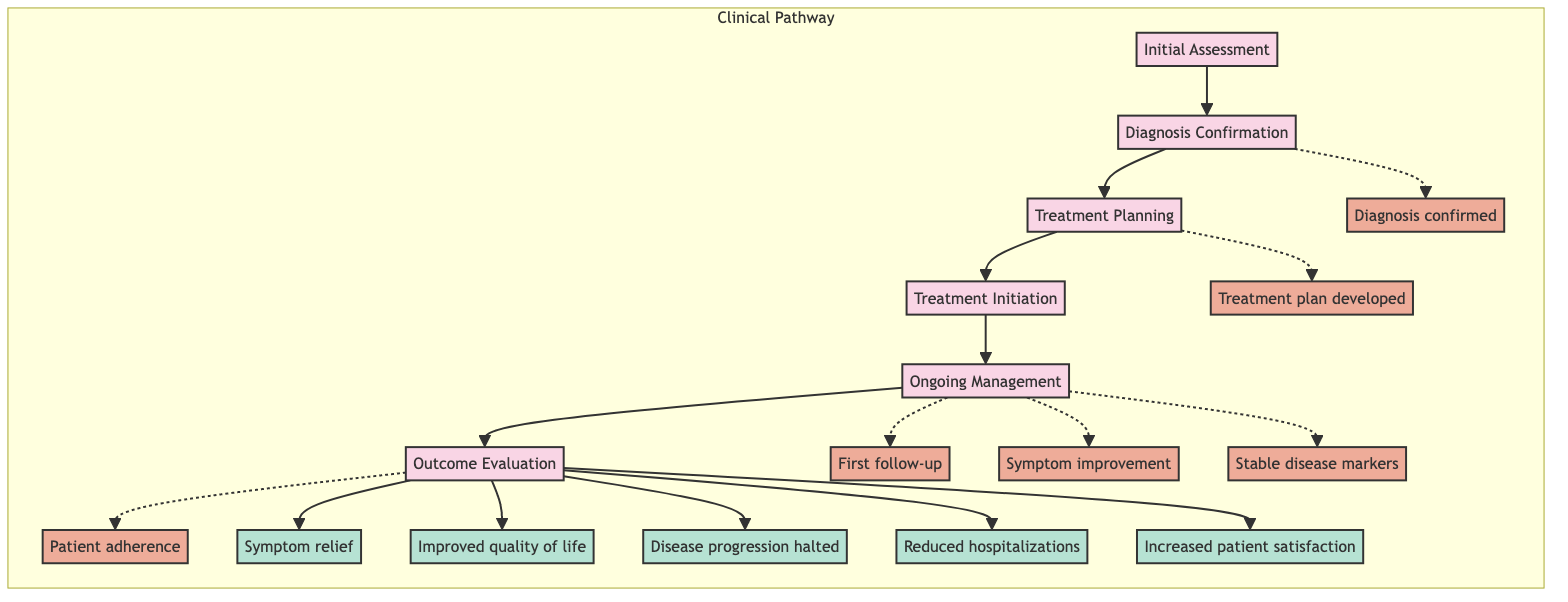What is the first stage in the clinical pathway? The diagram shows "Initial Assessment" at the beginning of the clinical pathway sequence.
Answer: Initial Assessment How many key milestones are presented in the diagram? The diagram lists a total of six milestones from "Diagnosis confirmed" to "Patient adherence."
Answer: 6 Which stage directly follows "Diagnosis Confirmation"? The flow of the diagram indicates that "Treatment Planning" comes immediately after "Diagnosis Confirmation."
Answer: Treatment Planning What outcome is associated with the final evaluation stage? The final stage, "Outcome Evaluation," is linked to several outcomes, one of which is "Increased patient satisfaction."
Answer: Increased patient satisfaction What is one of the steps involved in "Ongoing Management"? The steps under "Ongoing Management" include regular follow-up visits, which is one actionable item listed.
Answer: Regular follow-up visits What milestone follows the "Treatment plan developed"? The diagram indicates that "First follow-up" comes after the milestone of "Treatment plan developed."
Answer: First follow-up How does "Ongoing Management" contribute to symptom evaluation? "Ongoing Management" involves continuous monitoring, which leads to symptom improvement as outlined in the outcomes.
Answer: Symptom improvement Name one type of healthcare professional involved in "Treatment Planning." The steps mention coordinating with a "Nutritionist," among other multidisciplinary team members.
Answer: Nutritionist How many stages are outlined in the clinical pathway? The diagram explicitly shows six distinct stages from "Initial Assessment" to "Outcome Evaluation."
Answer: 6 